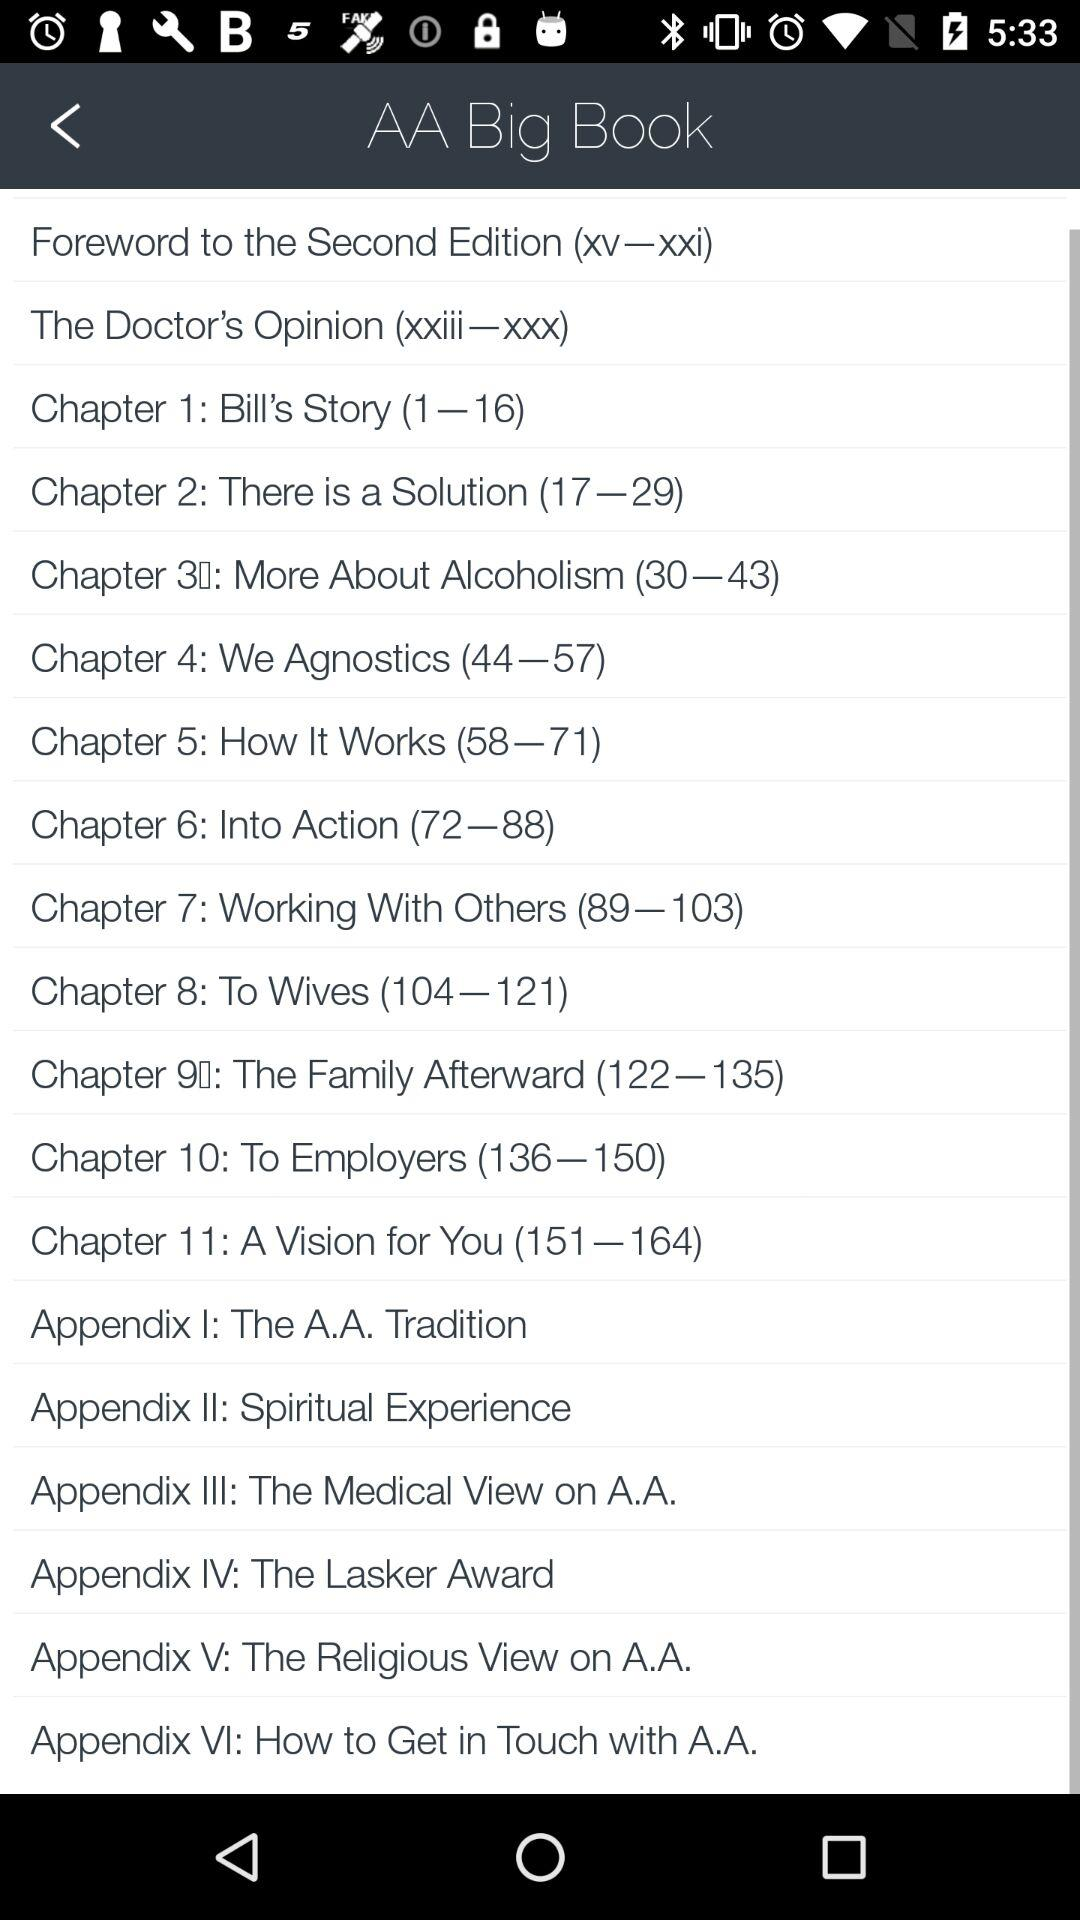How many chapters are in the AA Big Book?
Answer the question using a single word or phrase. 11 